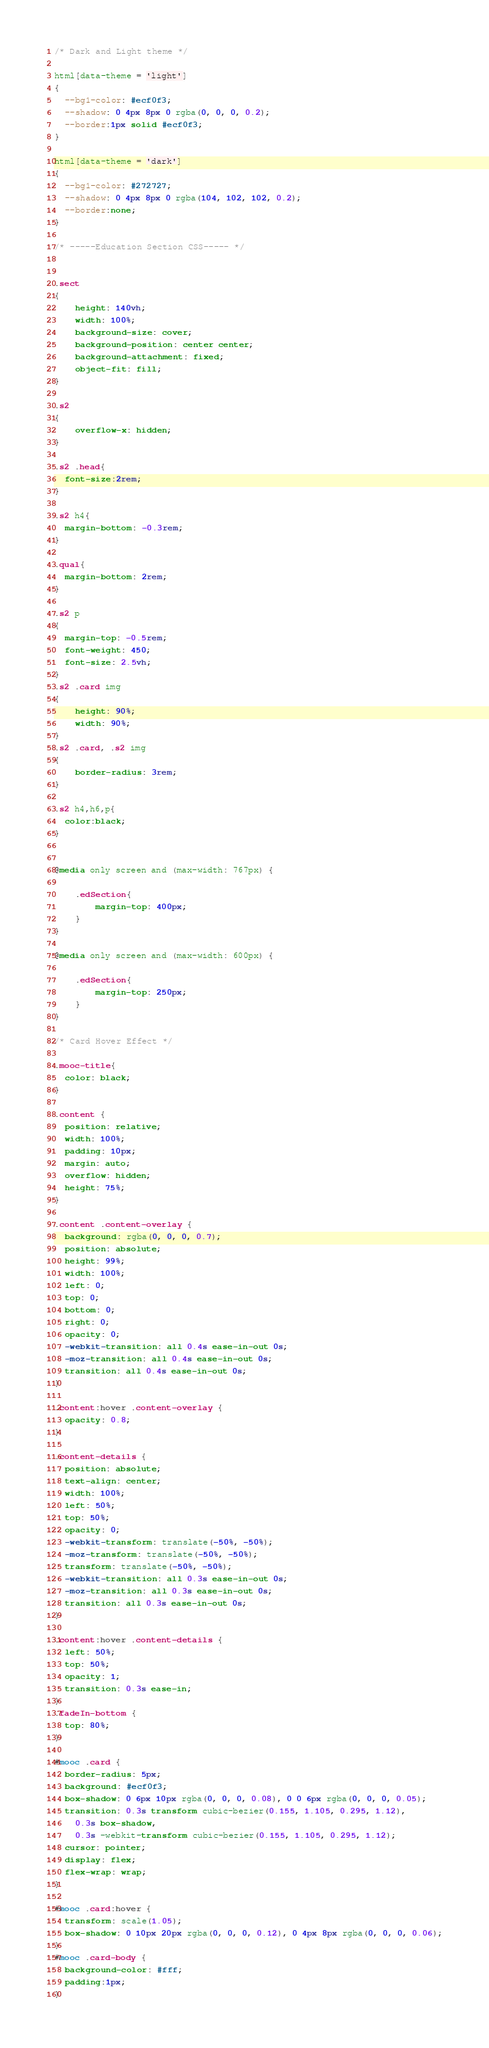<code> <loc_0><loc_0><loc_500><loc_500><_CSS_>/* Dark and Light theme */

html[data-theme = 'light']
{
  --bg1-color: #ecf0f3;
  --shadow: 0 4px 8px 0 rgba(0, 0, 0, 0.2);
  --border:1px solid #ecf0f3;
}

html[data-theme = 'dark']
{
  --bg1-color: #272727;
  --shadow: 0 4px 8px 0 rgba(104, 102, 102, 0.2);
  --border:none;
}

/* -----Education Section CSS----- */


.sect
{
    height: 140vh;
    width: 100%;
    background-size: cover;
    background-position: center center;
    background-attachment: fixed;
    object-fit: fill;
}

.s2
{
    overflow-x: hidden;
}

.s2 .head{
  font-size:2rem;
}

.s2 h4{
  margin-bottom: -0.3rem;
}

.qual{
  margin-bottom: 2rem;
}

.s2 p
{
  margin-top: -0.5rem;
  font-weight: 450;
  font-size: 2.5vh;
}
.s2 .card img
{
    height: 90%;
    width: 90%;
}
.s2 .card, .s2 img
{
    border-radius: 3rem;
}

.s2 h4,h6,p{
  color:black;
}


@media only screen and (max-width: 767px) {

    .edSection{
        margin-top: 400px;
    }
}

@media only screen and (max-width: 600px) {

    .edSection{
        margin-top: 250px;
    }
}

/* Card Hover Effect */

.mooc-title{
  color: black;
}

.content {
  position: relative;
  width: 100%;
  padding: 10px;
  margin: auto;
  overflow: hidden;
  height: 75%;
}

.content .content-overlay {
  background: rgba(0, 0, 0, 0.7);
  position: absolute;
  height: 99%;
  width: 100%;
  left: 0;
  top: 0;
  bottom: 0;
  right: 0;
  opacity: 0;
  -webkit-transition: all 0.4s ease-in-out 0s;
  -moz-transition: all 0.4s ease-in-out 0s;
  transition: all 0.4s ease-in-out 0s;
}

.content:hover .content-overlay {
  opacity: 0.8;
}

.content-details {
  position: absolute;
  text-align: center;
  width: 100%;
  left: 50%;
  top: 50%;
  opacity: 0;
  -webkit-transform: translate(-50%, -50%);
  -moz-transform: translate(-50%, -50%);
  transform: translate(-50%, -50%);
  -webkit-transition: all 0.3s ease-in-out 0s;
  -moz-transition: all 0.3s ease-in-out 0s;
  transition: all 0.3s ease-in-out 0s;
}

.content:hover .content-details {
  left: 50%;
  top: 50%;
  opacity: 1;
  transition: 0.3s ease-in;
}
.fadeIn-bottom {
  top: 80%;
}

#mooc .card {
  border-radius: 5px;
  background: #ecf0f3;
  box-shadow: 0 6px 10px rgba(0, 0, 0, 0.08), 0 0 6px rgba(0, 0, 0, 0.05);
  transition: 0.3s transform cubic-bezier(0.155, 1.105, 0.295, 1.12),
    0.3s box-shadow,
    0.3s -webkit-transform cubic-bezier(0.155, 1.105, 0.295, 1.12);
  cursor: pointer;
  display: flex;
  flex-wrap: wrap;
}

#mooc .card:hover {
  transform: scale(1.05);
  box-shadow: 0 10px 20px rgba(0, 0, 0, 0.12), 0 4px 8px rgba(0, 0, 0, 0.06);
}
#mooc .card-body {
  background-color: #fff;
  padding:1px;
}
</code> 